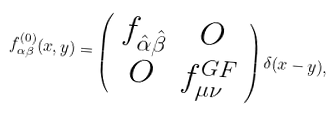Convert formula to latex. <formula><loc_0><loc_0><loc_500><loc_500>f ^ { ( 0 ) } _ { \alpha \beta } ( x , y ) = \left ( \begin{array} { c c } f _ { \hat { \alpha } \hat { \beta } } & O \\ O & f ^ { G F } _ { \mu \nu } \end{array} \right ) \delta ( x - y ) ,</formula> 